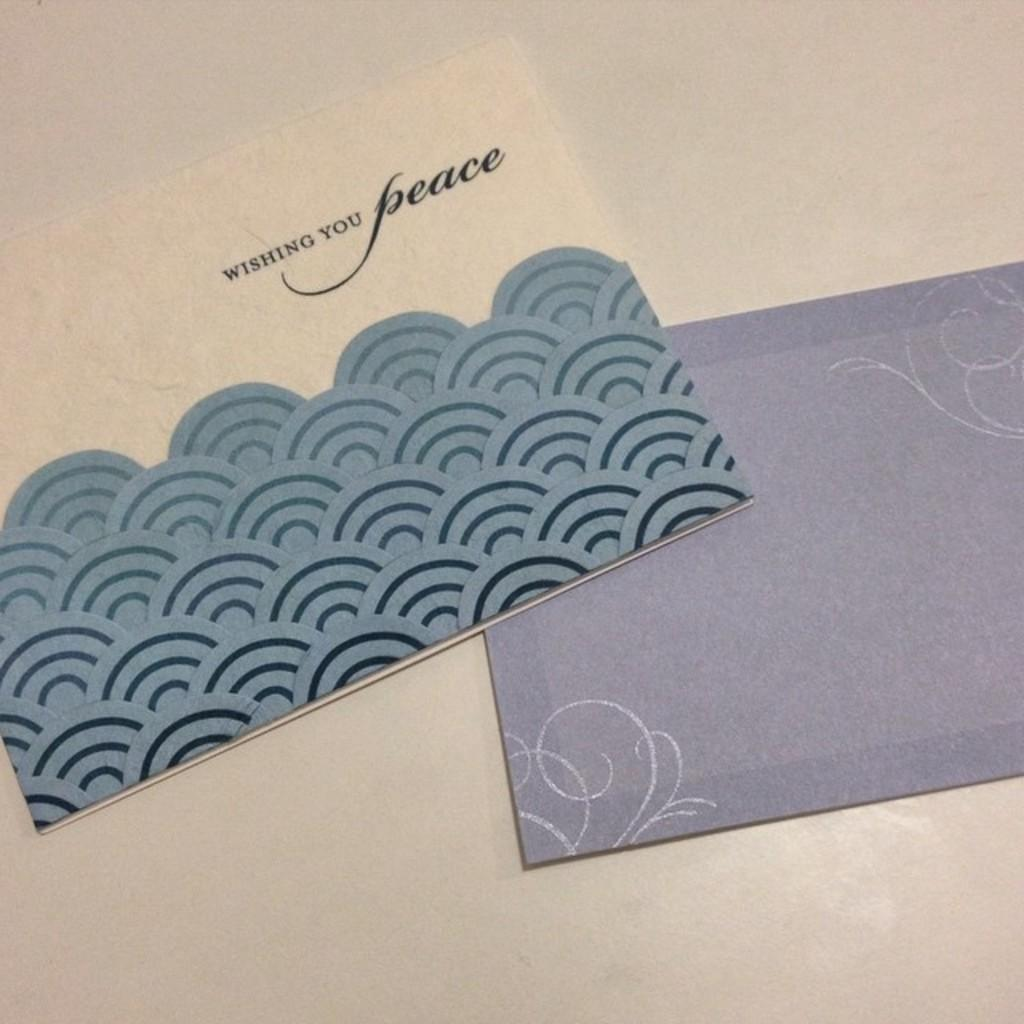<image>
Provide a brief description of the given image. A envelope and fancy card wish you peace. 